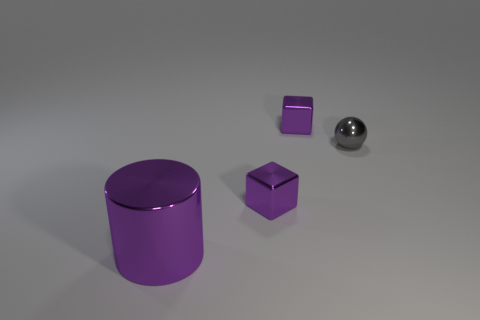Add 1 large purple shiny cylinders. How many objects exist? 5 Subtract all cylinders. How many objects are left? 3 Add 1 small green shiny cubes. How many small green shiny cubes exist? 1 Subtract 0 yellow cubes. How many objects are left? 4 Subtract all small cylinders. Subtract all large metal cylinders. How many objects are left? 3 Add 3 tiny balls. How many tiny balls are left? 4 